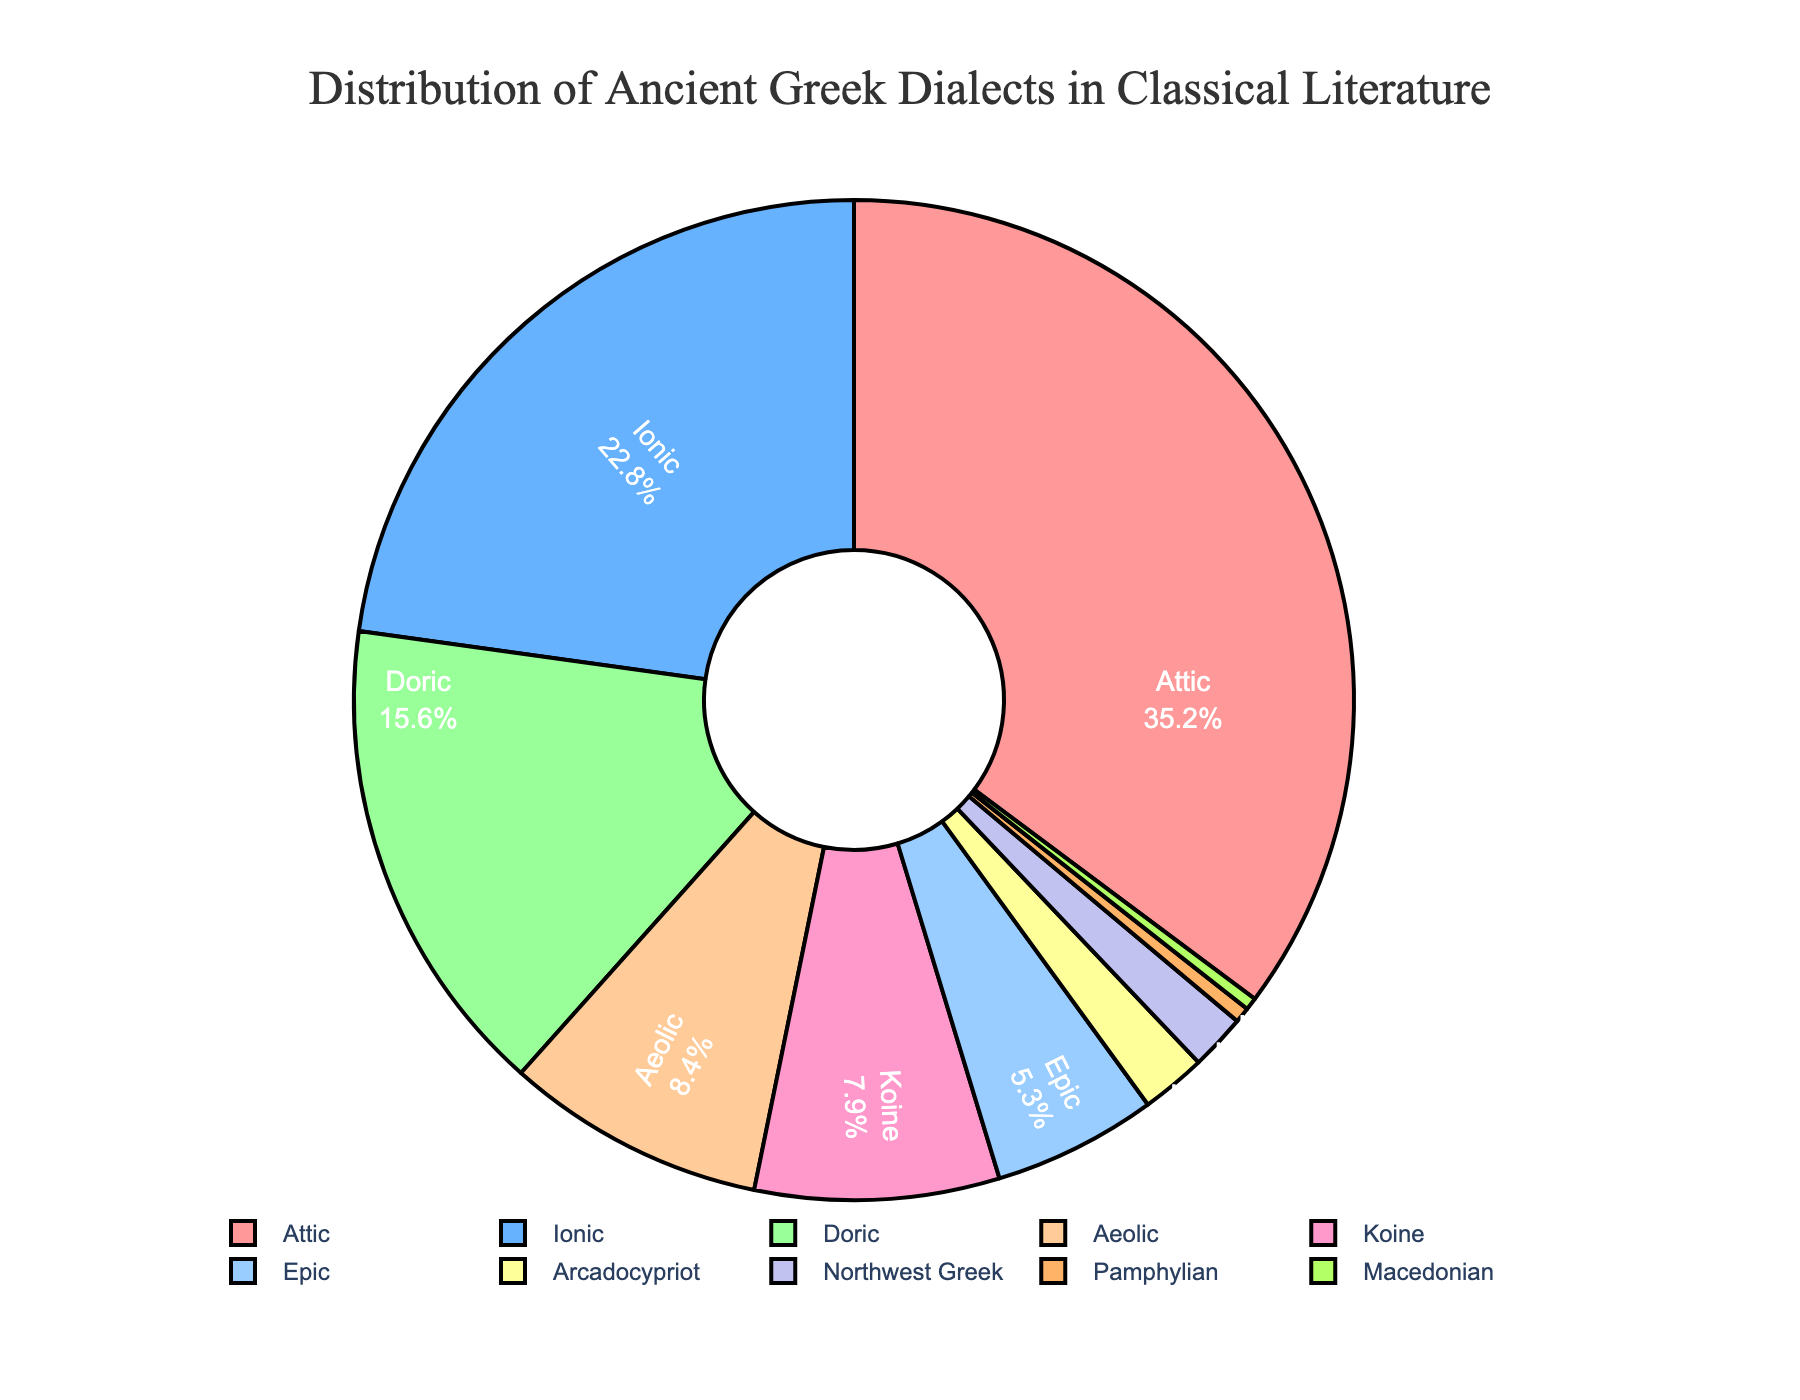What percentage of the pie chart is represented by the Attic and Ionic dialects combined? The Attic dialect represents 35.2% and the Ionic dialect represents 22.8%. Adding these percentages gives us 35.2 + 22.8 = 58.0%.
Answer: 58.0% Which dialect has a greater percentage: Doric or Aeolic? The Doric dialect has a percentage of 15.6% and the Aeolic dialect has a percentage of 8.4%. Since 15.6% is greater than 8.4%, the Doric dialect has a greater percentage than the Aeolic dialect.
Answer: Doric Which dialect segment is the smallest in the pie chart? By inspecting the percentages, we see that the Macedonian dialect has the smallest percentage at 0.4%.
Answer: Macedonian Are there more percentages combined in Koine and Epic dialects than in the Doric dialect? The Koine dialect is 7.9% and the Epic dialect is 5.3%. Adding these together gives us 7.9 + 5.3 = 13.2%. The Doric dialect is 15.6%. Since 13.2% is less than 15.6%, there are fewer percentages combined in Koine and Epic dialects than in the Doric dialect.
Answer: No Which color represents the Doric dialect in the pie chart? The Doric dialect is represented by the fourth segment, which is colored in light orange (#FFCC99).
Answer: light orange Arrange the top three dialects by percentage in descending order. From the highest to the lowest percentage, the top three dialects are Attic (35.2%), Ionic (22.8%), and Doric (15.6%).
Answer: Attic, Ionic, Doric How many dialects have a percentage greater than 10%? By examining the pie chart, we see that the Attic (35.2%), Ionic (22.8%), and Doric (15.6%) are the only dialects with percentages greater than 10%. Therefore, there are 3 dialects with a percentage greater than 10%.
Answer: 3 Which dialect has a percentage closest to 2%? The Arcadocypriot dialect has a percentage of 2.1%, which is closest to 2% compared to the next smallest percentage, which is Northwest Greek at 1.8%.
Answer: Arcadocypriot What is the total percentage of dialects that form less than 5% each? Adding the percentages of Epic (5.3%), Arcadocypriot (2.1%), Northwest Greek (1.8%), Pamphylian (0.5%), and Macedonian (0.4%) gives us 5.3 + 2.1 + 1.8 + 0.5 + 0.4 = 10.1%.
Answer: 10.1% Compare the share of Koine to Epic dialects and state which has a higher percentage and by how much. The Koine dialect has a percentage of 7.9%, and the Epic dialect has a percentage of 5.3%. Subtracting these gives 7.9 - 5.3 = 2.6%. Therefore, Koine has a higher percentage by 2.6%.
Answer: Koine by 2.6% 